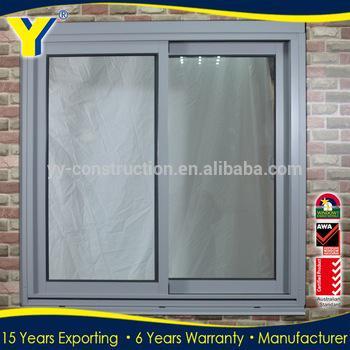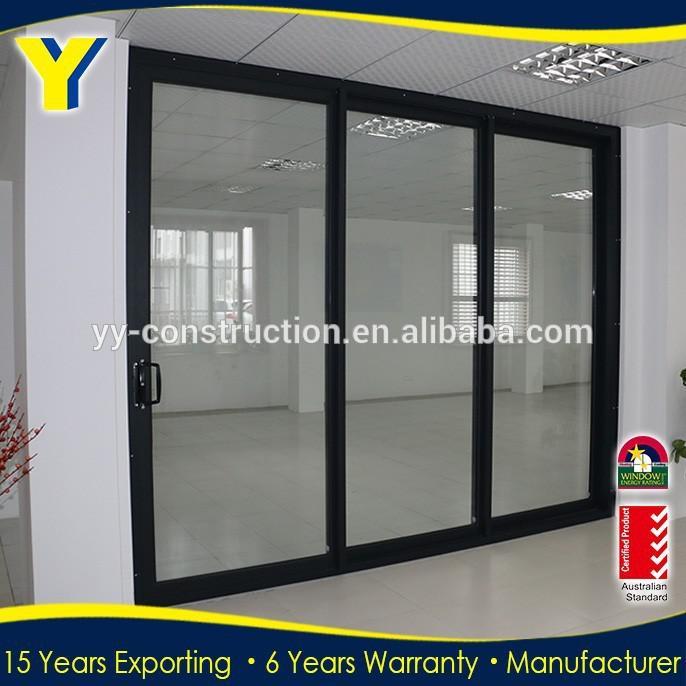The first image is the image on the left, the second image is the image on the right. Analyze the images presented: Is the assertion "An image shows a square sliding glass unit with just two side-by-side glass panes." valid? Answer yes or no. Yes. 